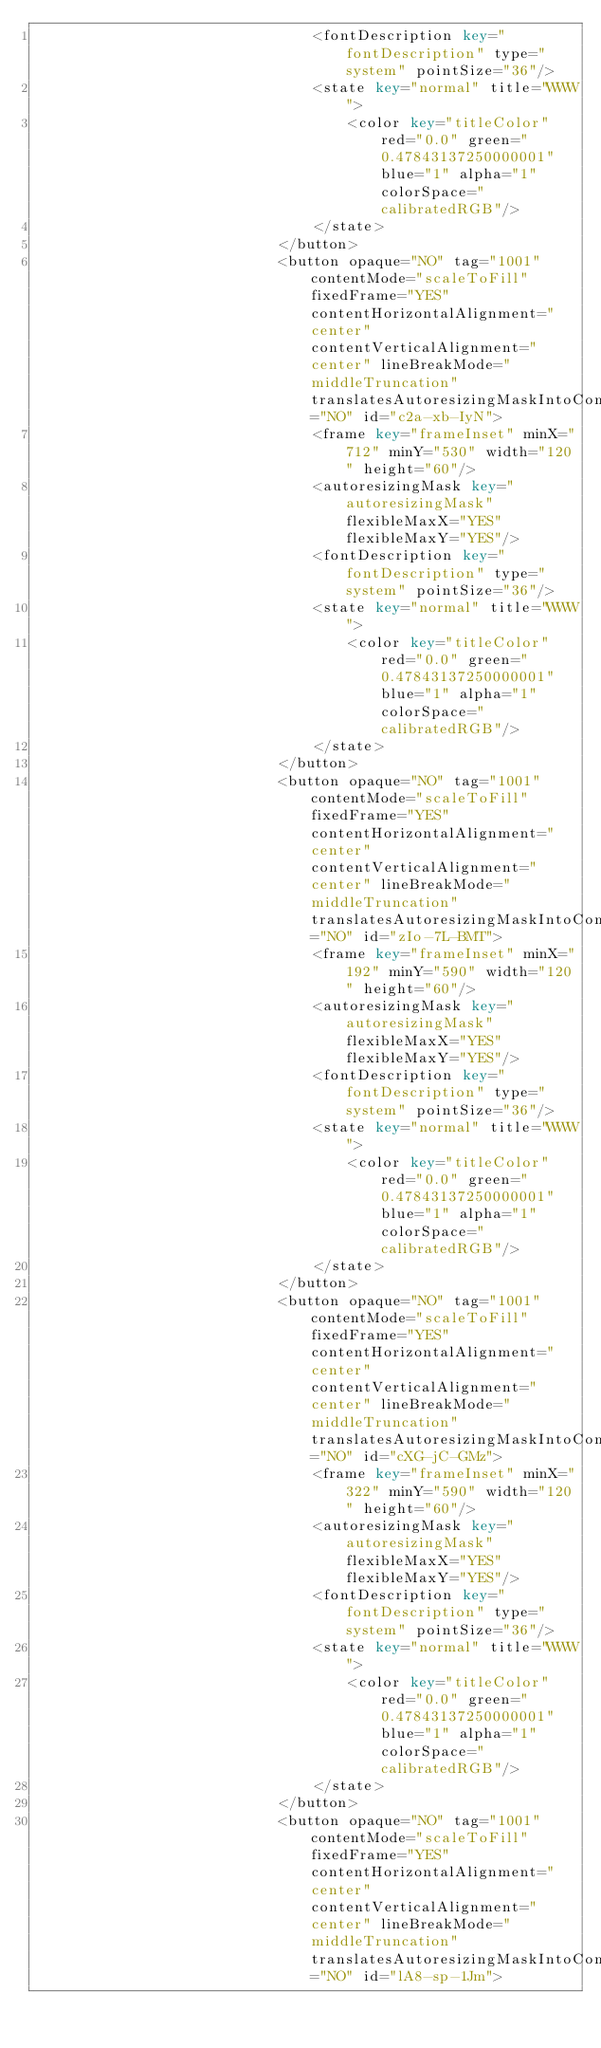Convert code to text. <code><loc_0><loc_0><loc_500><loc_500><_XML_>                                <fontDescription key="fontDescription" type="system" pointSize="36"/>
                                <state key="normal" title="WWW">
                                    <color key="titleColor" red="0.0" green="0.47843137250000001" blue="1" alpha="1" colorSpace="calibratedRGB"/>
                                </state>
                            </button>
                            <button opaque="NO" tag="1001" contentMode="scaleToFill" fixedFrame="YES" contentHorizontalAlignment="center" contentVerticalAlignment="center" lineBreakMode="middleTruncation" translatesAutoresizingMaskIntoConstraints="NO" id="c2a-xb-IyN">
                                <frame key="frameInset" minX="712" minY="530" width="120" height="60"/>
                                <autoresizingMask key="autoresizingMask" flexibleMaxX="YES" flexibleMaxY="YES"/>
                                <fontDescription key="fontDescription" type="system" pointSize="36"/>
                                <state key="normal" title="WWW">
                                    <color key="titleColor" red="0.0" green="0.47843137250000001" blue="1" alpha="1" colorSpace="calibratedRGB"/>
                                </state>
                            </button>
                            <button opaque="NO" tag="1001" contentMode="scaleToFill" fixedFrame="YES" contentHorizontalAlignment="center" contentVerticalAlignment="center" lineBreakMode="middleTruncation" translatesAutoresizingMaskIntoConstraints="NO" id="zIo-7L-BMT">
                                <frame key="frameInset" minX="192" minY="590" width="120" height="60"/>
                                <autoresizingMask key="autoresizingMask" flexibleMaxX="YES" flexibleMaxY="YES"/>
                                <fontDescription key="fontDescription" type="system" pointSize="36"/>
                                <state key="normal" title="WWW">
                                    <color key="titleColor" red="0.0" green="0.47843137250000001" blue="1" alpha="1" colorSpace="calibratedRGB"/>
                                </state>
                            </button>
                            <button opaque="NO" tag="1001" contentMode="scaleToFill" fixedFrame="YES" contentHorizontalAlignment="center" contentVerticalAlignment="center" lineBreakMode="middleTruncation" translatesAutoresizingMaskIntoConstraints="NO" id="cXG-jC-GMz">
                                <frame key="frameInset" minX="322" minY="590" width="120" height="60"/>
                                <autoresizingMask key="autoresizingMask" flexibleMaxX="YES" flexibleMaxY="YES"/>
                                <fontDescription key="fontDescription" type="system" pointSize="36"/>
                                <state key="normal" title="WWW">
                                    <color key="titleColor" red="0.0" green="0.47843137250000001" blue="1" alpha="1" colorSpace="calibratedRGB"/>
                                </state>
                            </button>
                            <button opaque="NO" tag="1001" contentMode="scaleToFill" fixedFrame="YES" contentHorizontalAlignment="center" contentVerticalAlignment="center" lineBreakMode="middleTruncation" translatesAutoresizingMaskIntoConstraints="NO" id="lA8-sp-1Jm"></code> 